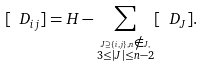<formula> <loc_0><loc_0><loc_500><loc_500>[ \ D _ { i j } ] = H - \sum _ { \stackrel { J \supseteq \{ i , j \} , n \notin J , } { 3 \leq | J | \leq n - 2 } } [ \ D _ { J } ] .</formula> 